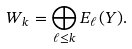<formula> <loc_0><loc_0><loc_500><loc_500>W _ { k } = \bigoplus _ { \ell \leq k } E _ { \ell } ( Y ) .</formula> 